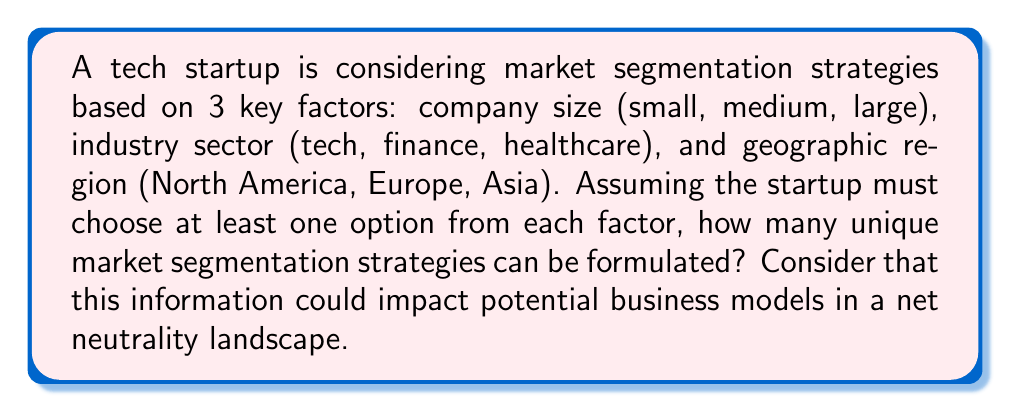What is the answer to this math problem? Let's approach this step-by-step:

1) For each factor, we have the following options:
   - Company size: 3 options (small, medium, large)
   - Industry sector: 3 options (tech, finance, healthcare)
   - Geographic region: 3 options (North America, Europe, Asia)

2) For each factor, the startup can choose any non-empty subset of options. This means we need to calculate the number of non-empty subsets for each factor.

3) For a set with $n$ elements, the number of non-empty subsets is $2^n - 1$.

4) In this case, each factor has 3 options, so for each factor we have:
   $2^3 - 1 = 8 - 1 = 7$ possible non-empty subsets

5) Now, we need to choose one subset for each factor. By the multiplication principle, we multiply the number of choices for each factor:

   $7 \times 7 \times 7 = 7^3 = 343$

This result represents the total number of unique market segmentation strategies that the startup can formulate, each of which could potentially be affected differently by net neutrality policies.
Answer: $343$ 